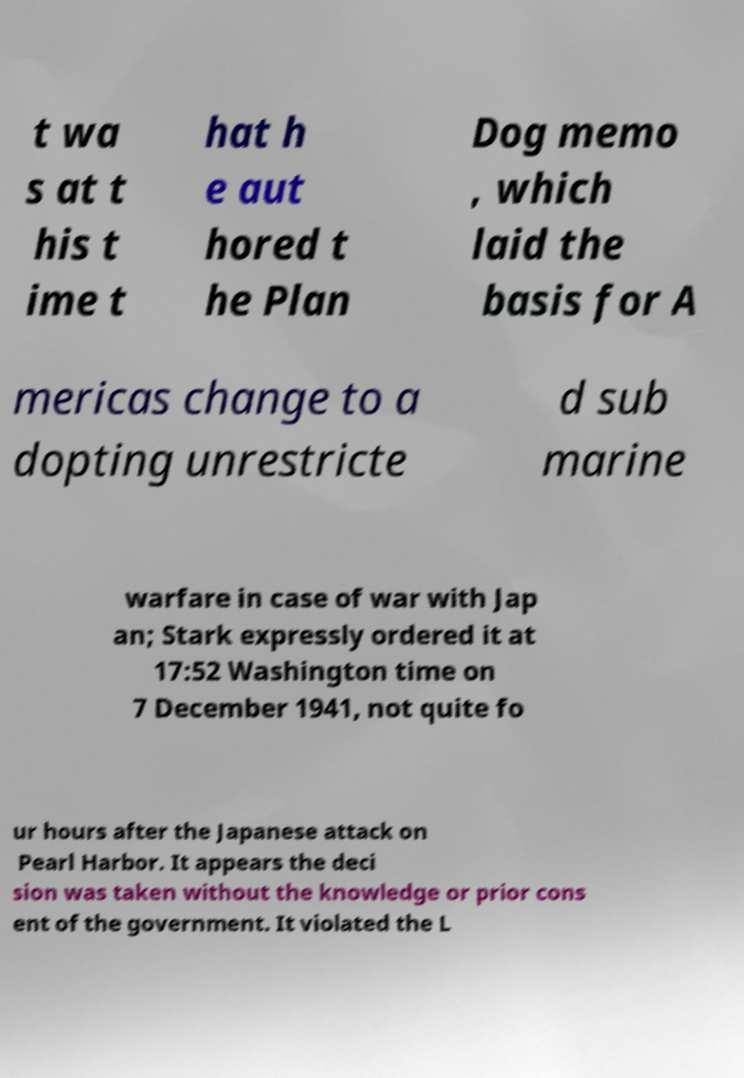Please identify and transcribe the text found in this image. t wa s at t his t ime t hat h e aut hored t he Plan Dog memo , which laid the basis for A mericas change to a dopting unrestricte d sub marine warfare in case of war with Jap an; Stark expressly ordered it at 17:52 Washington time on 7 December 1941, not quite fo ur hours after the Japanese attack on Pearl Harbor. It appears the deci sion was taken without the knowledge or prior cons ent of the government. It violated the L 